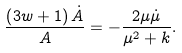Convert formula to latex. <formula><loc_0><loc_0><loc_500><loc_500>\frac { \left ( 3 w + 1 \right ) \dot { A } } { A } = - \frac { 2 \mu \dot { \mu } } { \mu ^ { 2 } + k } .</formula> 